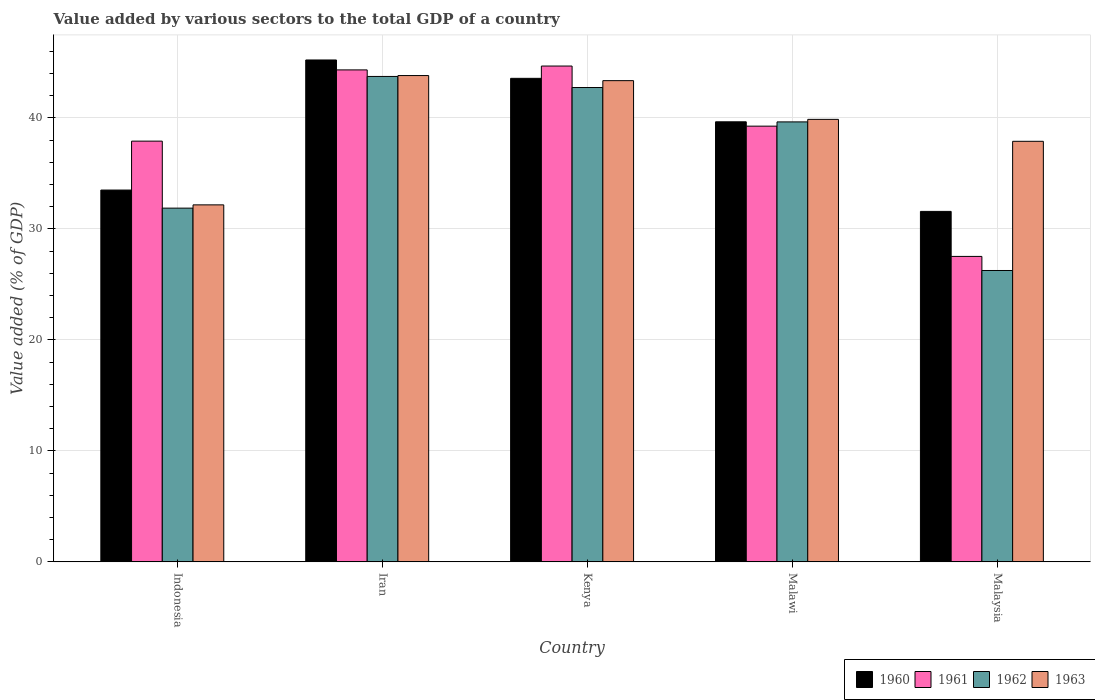How many different coloured bars are there?
Your response must be concise. 4. Are the number of bars per tick equal to the number of legend labels?
Your answer should be very brief. Yes. Are the number of bars on each tick of the X-axis equal?
Provide a succinct answer. Yes. What is the label of the 2nd group of bars from the left?
Provide a short and direct response. Iran. What is the value added by various sectors to the total GDP in 1960 in Indonesia?
Make the answer very short. 33.5. Across all countries, what is the maximum value added by various sectors to the total GDP in 1962?
Your answer should be very brief. 43.73. Across all countries, what is the minimum value added by various sectors to the total GDP in 1963?
Give a very brief answer. 32.16. In which country was the value added by various sectors to the total GDP in 1960 maximum?
Offer a terse response. Iran. In which country was the value added by various sectors to the total GDP in 1961 minimum?
Make the answer very short. Malaysia. What is the total value added by various sectors to the total GDP in 1960 in the graph?
Your response must be concise. 193.49. What is the difference between the value added by various sectors to the total GDP in 1960 in Iran and that in Malaysia?
Your response must be concise. 13.64. What is the difference between the value added by various sectors to the total GDP in 1963 in Malawi and the value added by various sectors to the total GDP in 1962 in Iran?
Offer a terse response. -3.87. What is the average value added by various sectors to the total GDP in 1960 per country?
Provide a succinct answer. 38.7. What is the difference between the value added by various sectors to the total GDP of/in 1961 and value added by various sectors to the total GDP of/in 1963 in Malaysia?
Offer a very short reply. -10.37. What is the ratio of the value added by various sectors to the total GDP in 1961 in Kenya to that in Malawi?
Your response must be concise. 1.14. Is the value added by various sectors to the total GDP in 1960 in Iran less than that in Malawi?
Give a very brief answer. No. What is the difference between the highest and the second highest value added by various sectors to the total GDP in 1963?
Give a very brief answer. -0.46. What is the difference between the highest and the lowest value added by various sectors to the total GDP in 1963?
Offer a terse response. 11.65. In how many countries, is the value added by various sectors to the total GDP in 1961 greater than the average value added by various sectors to the total GDP in 1961 taken over all countries?
Your answer should be very brief. 3. Is the sum of the value added by various sectors to the total GDP in 1960 in Indonesia and Kenya greater than the maximum value added by various sectors to the total GDP in 1961 across all countries?
Your response must be concise. Yes. What does the 2nd bar from the right in Malaysia represents?
Offer a very short reply. 1962. Is it the case that in every country, the sum of the value added by various sectors to the total GDP in 1963 and value added by various sectors to the total GDP in 1962 is greater than the value added by various sectors to the total GDP in 1960?
Make the answer very short. Yes. Are all the bars in the graph horizontal?
Your answer should be very brief. No. Are the values on the major ticks of Y-axis written in scientific E-notation?
Provide a succinct answer. No. Where does the legend appear in the graph?
Offer a terse response. Bottom right. How many legend labels are there?
Keep it short and to the point. 4. How are the legend labels stacked?
Your answer should be very brief. Horizontal. What is the title of the graph?
Offer a very short reply. Value added by various sectors to the total GDP of a country. What is the label or title of the Y-axis?
Provide a short and direct response. Value added (% of GDP). What is the Value added (% of GDP) in 1960 in Indonesia?
Ensure brevity in your answer.  33.5. What is the Value added (% of GDP) in 1961 in Indonesia?
Ensure brevity in your answer.  37.9. What is the Value added (% of GDP) of 1962 in Indonesia?
Ensure brevity in your answer.  31.87. What is the Value added (% of GDP) of 1963 in Indonesia?
Ensure brevity in your answer.  32.16. What is the Value added (% of GDP) of 1960 in Iran?
Your answer should be compact. 45.21. What is the Value added (% of GDP) of 1961 in Iran?
Offer a terse response. 44.32. What is the Value added (% of GDP) in 1962 in Iran?
Give a very brief answer. 43.73. What is the Value added (% of GDP) of 1963 in Iran?
Your answer should be very brief. 43.81. What is the Value added (% of GDP) of 1960 in Kenya?
Give a very brief answer. 43.56. What is the Value added (% of GDP) in 1961 in Kenya?
Your answer should be compact. 44.67. What is the Value added (% of GDP) of 1962 in Kenya?
Your answer should be very brief. 42.73. What is the Value added (% of GDP) in 1963 in Kenya?
Keep it short and to the point. 43.35. What is the Value added (% of GDP) in 1960 in Malawi?
Your answer should be very brief. 39.64. What is the Value added (% of GDP) in 1961 in Malawi?
Give a very brief answer. 39.25. What is the Value added (% of GDP) in 1962 in Malawi?
Make the answer very short. 39.64. What is the Value added (% of GDP) of 1963 in Malawi?
Keep it short and to the point. 39.86. What is the Value added (% of GDP) in 1960 in Malaysia?
Your answer should be compact. 31.57. What is the Value added (% of GDP) of 1961 in Malaysia?
Your answer should be very brief. 27.52. What is the Value added (% of GDP) of 1962 in Malaysia?
Your response must be concise. 26.25. What is the Value added (% of GDP) of 1963 in Malaysia?
Give a very brief answer. 37.89. Across all countries, what is the maximum Value added (% of GDP) of 1960?
Your answer should be compact. 45.21. Across all countries, what is the maximum Value added (% of GDP) in 1961?
Provide a succinct answer. 44.67. Across all countries, what is the maximum Value added (% of GDP) in 1962?
Provide a succinct answer. 43.73. Across all countries, what is the maximum Value added (% of GDP) in 1963?
Provide a short and direct response. 43.81. Across all countries, what is the minimum Value added (% of GDP) in 1960?
Offer a very short reply. 31.57. Across all countries, what is the minimum Value added (% of GDP) in 1961?
Your answer should be very brief. 27.52. Across all countries, what is the minimum Value added (% of GDP) of 1962?
Make the answer very short. 26.25. Across all countries, what is the minimum Value added (% of GDP) in 1963?
Ensure brevity in your answer.  32.16. What is the total Value added (% of GDP) of 1960 in the graph?
Offer a terse response. 193.49. What is the total Value added (% of GDP) of 1961 in the graph?
Your response must be concise. 193.66. What is the total Value added (% of GDP) in 1962 in the graph?
Ensure brevity in your answer.  184.21. What is the total Value added (% of GDP) of 1963 in the graph?
Your answer should be compact. 197.08. What is the difference between the Value added (% of GDP) in 1960 in Indonesia and that in Iran?
Give a very brief answer. -11.72. What is the difference between the Value added (% of GDP) of 1961 in Indonesia and that in Iran?
Your answer should be very brief. -6.42. What is the difference between the Value added (% of GDP) of 1962 in Indonesia and that in Iran?
Your answer should be compact. -11.86. What is the difference between the Value added (% of GDP) in 1963 in Indonesia and that in Iran?
Provide a succinct answer. -11.65. What is the difference between the Value added (% of GDP) in 1960 in Indonesia and that in Kenya?
Provide a short and direct response. -10.06. What is the difference between the Value added (% of GDP) of 1961 in Indonesia and that in Kenya?
Make the answer very short. -6.76. What is the difference between the Value added (% of GDP) of 1962 in Indonesia and that in Kenya?
Your response must be concise. -10.87. What is the difference between the Value added (% of GDP) in 1963 in Indonesia and that in Kenya?
Give a very brief answer. -11.19. What is the difference between the Value added (% of GDP) in 1960 in Indonesia and that in Malawi?
Provide a short and direct response. -6.15. What is the difference between the Value added (% of GDP) of 1961 in Indonesia and that in Malawi?
Make the answer very short. -1.35. What is the difference between the Value added (% of GDP) of 1962 in Indonesia and that in Malawi?
Offer a very short reply. -7.77. What is the difference between the Value added (% of GDP) of 1963 in Indonesia and that in Malawi?
Your answer should be compact. -7.7. What is the difference between the Value added (% of GDP) in 1960 in Indonesia and that in Malaysia?
Give a very brief answer. 1.92. What is the difference between the Value added (% of GDP) in 1961 in Indonesia and that in Malaysia?
Give a very brief answer. 10.39. What is the difference between the Value added (% of GDP) in 1962 in Indonesia and that in Malaysia?
Keep it short and to the point. 5.62. What is the difference between the Value added (% of GDP) of 1963 in Indonesia and that in Malaysia?
Keep it short and to the point. -5.73. What is the difference between the Value added (% of GDP) of 1960 in Iran and that in Kenya?
Provide a succinct answer. 1.65. What is the difference between the Value added (% of GDP) of 1961 in Iran and that in Kenya?
Offer a terse response. -0.35. What is the difference between the Value added (% of GDP) of 1962 in Iran and that in Kenya?
Give a very brief answer. 1. What is the difference between the Value added (% of GDP) of 1963 in Iran and that in Kenya?
Offer a very short reply. 0.46. What is the difference between the Value added (% of GDP) of 1960 in Iran and that in Malawi?
Provide a succinct answer. 5.57. What is the difference between the Value added (% of GDP) in 1961 in Iran and that in Malawi?
Provide a succinct answer. 5.07. What is the difference between the Value added (% of GDP) in 1962 in Iran and that in Malawi?
Make the answer very short. 4.09. What is the difference between the Value added (% of GDP) of 1963 in Iran and that in Malawi?
Ensure brevity in your answer.  3.95. What is the difference between the Value added (% of GDP) of 1960 in Iran and that in Malaysia?
Offer a terse response. 13.64. What is the difference between the Value added (% of GDP) in 1961 in Iran and that in Malaysia?
Ensure brevity in your answer.  16.8. What is the difference between the Value added (% of GDP) in 1962 in Iran and that in Malaysia?
Offer a terse response. 17.48. What is the difference between the Value added (% of GDP) in 1963 in Iran and that in Malaysia?
Provide a succinct answer. 5.92. What is the difference between the Value added (% of GDP) in 1960 in Kenya and that in Malawi?
Make the answer very short. 3.92. What is the difference between the Value added (% of GDP) of 1961 in Kenya and that in Malawi?
Provide a short and direct response. 5.41. What is the difference between the Value added (% of GDP) of 1962 in Kenya and that in Malawi?
Provide a short and direct response. 3.1. What is the difference between the Value added (% of GDP) in 1963 in Kenya and that in Malawi?
Offer a terse response. 3.49. What is the difference between the Value added (% of GDP) of 1960 in Kenya and that in Malaysia?
Offer a terse response. 11.99. What is the difference between the Value added (% of GDP) of 1961 in Kenya and that in Malaysia?
Keep it short and to the point. 17.15. What is the difference between the Value added (% of GDP) of 1962 in Kenya and that in Malaysia?
Make the answer very short. 16.48. What is the difference between the Value added (% of GDP) of 1963 in Kenya and that in Malaysia?
Your response must be concise. 5.46. What is the difference between the Value added (% of GDP) of 1960 in Malawi and that in Malaysia?
Your answer should be compact. 8.07. What is the difference between the Value added (% of GDP) in 1961 in Malawi and that in Malaysia?
Ensure brevity in your answer.  11.73. What is the difference between the Value added (% of GDP) of 1962 in Malawi and that in Malaysia?
Offer a terse response. 13.39. What is the difference between the Value added (% of GDP) of 1963 in Malawi and that in Malaysia?
Offer a terse response. 1.98. What is the difference between the Value added (% of GDP) in 1960 in Indonesia and the Value added (% of GDP) in 1961 in Iran?
Your response must be concise. -10.82. What is the difference between the Value added (% of GDP) in 1960 in Indonesia and the Value added (% of GDP) in 1962 in Iran?
Give a very brief answer. -10.24. What is the difference between the Value added (% of GDP) of 1960 in Indonesia and the Value added (% of GDP) of 1963 in Iran?
Make the answer very short. -10.32. What is the difference between the Value added (% of GDP) in 1961 in Indonesia and the Value added (% of GDP) in 1962 in Iran?
Make the answer very short. -5.83. What is the difference between the Value added (% of GDP) in 1961 in Indonesia and the Value added (% of GDP) in 1963 in Iran?
Give a very brief answer. -5.91. What is the difference between the Value added (% of GDP) in 1962 in Indonesia and the Value added (% of GDP) in 1963 in Iran?
Your response must be concise. -11.94. What is the difference between the Value added (% of GDP) of 1960 in Indonesia and the Value added (% of GDP) of 1961 in Kenya?
Your response must be concise. -11.17. What is the difference between the Value added (% of GDP) of 1960 in Indonesia and the Value added (% of GDP) of 1962 in Kenya?
Ensure brevity in your answer.  -9.24. What is the difference between the Value added (% of GDP) of 1960 in Indonesia and the Value added (% of GDP) of 1963 in Kenya?
Offer a terse response. -9.86. What is the difference between the Value added (% of GDP) in 1961 in Indonesia and the Value added (% of GDP) in 1962 in Kenya?
Ensure brevity in your answer.  -4.83. What is the difference between the Value added (% of GDP) of 1961 in Indonesia and the Value added (% of GDP) of 1963 in Kenya?
Keep it short and to the point. -5.45. What is the difference between the Value added (% of GDP) of 1962 in Indonesia and the Value added (% of GDP) of 1963 in Kenya?
Make the answer very short. -11.48. What is the difference between the Value added (% of GDP) in 1960 in Indonesia and the Value added (% of GDP) in 1961 in Malawi?
Make the answer very short. -5.76. What is the difference between the Value added (% of GDP) in 1960 in Indonesia and the Value added (% of GDP) in 1962 in Malawi?
Keep it short and to the point. -6.14. What is the difference between the Value added (% of GDP) of 1960 in Indonesia and the Value added (% of GDP) of 1963 in Malawi?
Provide a succinct answer. -6.37. What is the difference between the Value added (% of GDP) in 1961 in Indonesia and the Value added (% of GDP) in 1962 in Malawi?
Offer a very short reply. -1.73. What is the difference between the Value added (% of GDP) of 1961 in Indonesia and the Value added (% of GDP) of 1963 in Malawi?
Make the answer very short. -1.96. What is the difference between the Value added (% of GDP) of 1962 in Indonesia and the Value added (% of GDP) of 1963 in Malawi?
Offer a very short reply. -8. What is the difference between the Value added (% of GDP) of 1960 in Indonesia and the Value added (% of GDP) of 1961 in Malaysia?
Offer a very short reply. 5.98. What is the difference between the Value added (% of GDP) of 1960 in Indonesia and the Value added (% of GDP) of 1962 in Malaysia?
Give a very brief answer. 7.25. What is the difference between the Value added (% of GDP) in 1960 in Indonesia and the Value added (% of GDP) in 1963 in Malaysia?
Provide a succinct answer. -4.39. What is the difference between the Value added (% of GDP) in 1961 in Indonesia and the Value added (% of GDP) in 1962 in Malaysia?
Ensure brevity in your answer.  11.65. What is the difference between the Value added (% of GDP) in 1961 in Indonesia and the Value added (% of GDP) in 1963 in Malaysia?
Make the answer very short. 0.02. What is the difference between the Value added (% of GDP) in 1962 in Indonesia and the Value added (% of GDP) in 1963 in Malaysia?
Offer a terse response. -6.02. What is the difference between the Value added (% of GDP) in 1960 in Iran and the Value added (% of GDP) in 1961 in Kenya?
Give a very brief answer. 0.55. What is the difference between the Value added (% of GDP) in 1960 in Iran and the Value added (% of GDP) in 1962 in Kenya?
Keep it short and to the point. 2.48. What is the difference between the Value added (% of GDP) of 1960 in Iran and the Value added (% of GDP) of 1963 in Kenya?
Offer a very short reply. 1.86. What is the difference between the Value added (% of GDP) of 1961 in Iran and the Value added (% of GDP) of 1962 in Kenya?
Provide a succinct answer. 1.59. What is the difference between the Value added (% of GDP) in 1961 in Iran and the Value added (% of GDP) in 1963 in Kenya?
Your answer should be compact. 0.97. What is the difference between the Value added (% of GDP) in 1962 in Iran and the Value added (% of GDP) in 1963 in Kenya?
Offer a very short reply. 0.38. What is the difference between the Value added (% of GDP) of 1960 in Iran and the Value added (% of GDP) of 1961 in Malawi?
Keep it short and to the point. 5.96. What is the difference between the Value added (% of GDP) in 1960 in Iran and the Value added (% of GDP) in 1962 in Malawi?
Make the answer very short. 5.58. What is the difference between the Value added (% of GDP) of 1960 in Iran and the Value added (% of GDP) of 1963 in Malawi?
Your answer should be compact. 5.35. What is the difference between the Value added (% of GDP) of 1961 in Iran and the Value added (% of GDP) of 1962 in Malawi?
Your answer should be very brief. 4.68. What is the difference between the Value added (% of GDP) of 1961 in Iran and the Value added (% of GDP) of 1963 in Malawi?
Give a very brief answer. 4.46. What is the difference between the Value added (% of GDP) in 1962 in Iran and the Value added (% of GDP) in 1963 in Malawi?
Ensure brevity in your answer.  3.87. What is the difference between the Value added (% of GDP) of 1960 in Iran and the Value added (% of GDP) of 1961 in Malaysia?
Give a very brief answer. 17.7. What is the difference between the Value added (% of GDP) in 1960 in Iran and the Value added (% of GDP) in 1962 in Malaysia?
Ensure brevity in your answer.  18.96. What is the difference between the Value added (% of GDP) of 1960 in Iran and the Value added (% of GDP) of 1963 in Malaysia?
Your response must be concise. 7.33. What is the difference between the Value added (% of GDP) in 1961 in Iran and the Value added (% of GDP) in 1962 in Malaysia?
Give a very brief answer. 18.07. What is the difference between the Value added (% of GDP) of 1961 in Iran and the Value added (% of GDP) of 1963 in Malaysia?
Offer a terse response. 6.43. What is the difference between the Value added (% of GDP) in 1962 in Iran and the Value added (% of GDP) in 1963 in Malaysia?
Your answer should be compact. 5.84. What is the difference between the Value added (% of GDP) in 1960 in Kenya and the Value added (% of GDP) in 1961 in Malawi?
Your answer should be very brief. 4.31. What is the difference between the Value added (% of GDP) in 1960 in Kenya and the Value added (% of GDP) in 1962 in Malawi?
Give a very brief answer. 3.92. What is the difference between the Value added (% of GDP) in 1960 in Kenya and the Value added (% of GDP) in 1963 in Malawi?
Ensure brevity in your answer.  3.7. What is the difference between the Value added (% of GDP) in 1961 in Kenya and the Value added (% of GDP) in 1962 in Malawi?
Give a very brief answer. 5.03. What is the difference between the Value added (% of GDP) in 1961 in Kenya and the Value added (% of GDP) in 1963 in Malawi?
Your answer should be compact. 4.8. What is the difference between the Value added (% of GDP) in 1962 in Kenya and the Value added (% of GDP) in 1963 in Malawi?
Ensure brevity in your answer.  2.87. What is the difference between the Value added (% of GDP) of 1960 in Kenya and the Value added (% of GDP) of 1961 in Malaysia?
Give a very brief answer. 16.04. What is the difference between the Value added (% of GDP) in 1960 in Kenya and the Value added (% of GDP) in 1962 in Malaysia?
Provide a succinct answer. 17.31. What is the difference between the Value added (% of GDP) in 1960 in Kenya and the Value added (% of GDP) in 1963 in Malaysia?
Give a very brief answer. 5.67. What is the difference between the Value added (% of GDP) in 1961 in Kenya and the Value added (% of GDP) in 1962 in Malaysia?
Offer a terse response. 18.42. What is the difference between the Value added (% of GDP) in 1961 in Kenya and the Value added (% of GDP) in 1963 in Malaysia?
Provide a succinct answer. 6.78. What is the difference between the Value added (% of GDP) of 1962 in Kenya and the Value added (% of GDP) of 1963 in Malaysia?
Offer a very short reply. 4.84. What is the difference between the Value added (% of GDP) in 1960 in Malawi and the Value added (% of GDP) in 1961 in Malaysia?
Provide a short and direct response. 12.13. What is the difference between the Value added (% of GDP) of 1960 in Malawi and the Value added (% of GDP) of 1962 in Malaysia?
Offer a very short reply. 13.39. What is the difference between the Value added (% of GDP) of 1960 in Malawi and the Value added (% of GDP) of 1963 in Malaysia?
Provide a short and direct response. 1.76. What is the difference between the Value added (% of GDP) of 1961 in Malawi and the Value added (% of GDP) of 1962 in Malaysia?
Your answer should be compact. 13. What is the difference between the Value added (% of GDP) in 1961 in Malawi and the Value added (% of GDP) in 1963 in Malaysia?
Provide a short and direct response. 1.37. What is the difference between the Value added (% of GDP) of 1962 in Malawi and the Value added (% of GDP) of 1963 in Malaysia?
Give a very brief answer. 1.75. What is the average Value added (% of GDP) in 1960 per country?
Give a very brief answer. 38.7. What is the average Value added (% of GDP) in 1961 per country?
Your answer should be very brief. 38.73. What is the average Value added (% of GDP) in 1962 per country?
Ensure brevity in your answer.  36.84. What is the average Value added (% of GDP) in 1963 per country?
Your response must be concise. 39.41. What is the difference between the Value added (% of GDP) of 1960 and Value added (% of GDP) of 1961 in Indonesia?
Give a very brief answer. -4.41. What is the difference between the Value added (% of GDP) in 1960 and Value added (% of GDP) in 1962 in Indonesia?
Your response must be concise. 1.63. What is the difference between the Value added (% of GDP) of 1961 and Value added (% of GDP) of 1962 in Indonesia?
Your answer should be very brief. 6.04. What is the difference between the Value added (% of GDP) of 1961 and Value added (% of GDP) of 1963 in Indonesia?
Keep it short and to the point. 5.74. What is the difference between the Value added (% of GDP) of 1962 and Value added (% of GDP) of 1963 in Indonesia?
Ensure brevity in your answer.  -0.3. What is the difference between the Value added (% of GDP) of 1960 and Value added (% of GDP) of 1961 in Iran?
Your answer should be very brief. 0.89. What is the difference between the Value added (% of GDP) of 1960 and Value added (% of GDP) of 1962 in Iran?
Your response must be concise. 1.48. What is the difference between the Value added (% of GDP) in 1960 and Value added (% of GDP) in 1963 in Iran?
Your response must be concise. 1.4. What is the difference between the Value added (% of GDP) in 1961 and Value added (% of GDP) in 1962 in Iran?
Give a very brief answer. 0.59. What is the difference between the Value added (% of GDP) in 1961 and Value added (% of GDP) in 1963 in Iran?
Make the answer very short. 0.51. What is the difference between the Value added (% of GDP) in 1962 and Value added (% of GDP) in 1963 in Iran?
Offer a very short reply. -0.08. What is the difference between the Value added (% of GDP) of 1960 and Value added (% of GDP) of 1961 in Kenya?
Ensure brevity in your answer.  -1.11. What is the difference between the Value added (% of GDP) in 1960 and Value added (% of GDP) in 1962 in Kenya?
Provide a short and direct response. 0.83. What is the difference between the Value added (% of GDP) in 1960 and Value added (% of GDP) in 1963 in Kenya?
Provide a succinct answer. 0.21. What is the difference between the Value added (% of GDP) in 1961 and Value added (% of GDP) in 1962 in Kenya?
Your response must be concise. 1.94. What is the difference between the Value added (% of GDP) of 1961 and Value added (% of GDP) of 1963 in Kenya?
Give a very brief answer. 1.32. What is the difference between the Value added (% of GDP) in 1962 and Value added (% of GDP) in 1963 in Kenya?
Provide a succinct answer. -0.62. What is the difference between the Value added (% of GDP) in 1960 and Value added (% of GDP) in 1961 in Malawi?
Keep it short and to the point. 0.39. What is the difference between the Value added (% of GDP) in 1960 and Value added (% of GDP) in 1962 in Malawi?
Your answer should be very brief. 0.01. What is the difference between the Value added (% of GDP) in 1960 and Value added (% of GDP) in 1963 in Malawi?
Your response must be concise. -0.22. What is the difference between the Value added (% of GDP) of 1961 and Value added (% of GDP) of 1962 in Malawi?
Provide a succinct answer. -0.38. What is the difference between the Value added (% of GDP) of 1961 and Value added (% of GDP) of 1963 in Malawi?
Offer a terse response. -0.61. What is the difference between the Value added (% of GDP) in 1962 and Value added (% of GDP) in 1963 in Malawi?
Provide a short and direct response. -0.23. What is the difference between the Value added (% of GDP) of 1960 and Value added (% of GDP) of 1961 in Malaysia?
Provide a short and direct response. 4.05. What is the difference between the Value added (% of GDP) of 1960 and Value added (% of GDP) of 1962 in Malaysia?
Your answer should be very brief. 5.32. What is the difference between the Value added (% of GDP) in 1960 and Value added (% of GDP) in 1963 in Malaysia?
Ensure brevity in your answer.  -6.31. What is the difference between the Value added (% of GDP) in 1961 and Value added (% of GDP) in 1962 in Malaysia?
Your response must be concise. 1.27. What is the difference between the Value added (% of GDP) of 1961 and Value added (% of GDP) of 1963 in Malaysia?
Keep it short and to the point. -10.37. What is the difference between the Value added (% of GDP) in 1962 and Value added (% of GDP) in 1963 in Malaysia?
Give a very brief answer. -11.64. What is the ratio of the Value added (% of GDP) of 1960 in Indonesia to that in Iran?
Your answer should be very brief. 0.74. What is the ratio of the Value added (% of GDP) of 1961 in Indonesia to that in Iran?
Your answer should be compact. 0.86. What is the ratio of the Value added (% of GDP) in 1962 in Indonesia to that in Iran?
Your answer should be very brief. 0.73. What is the ratio of the Value added (% of GDP) in 1963 in Indonesia to that in Iran?
Ensure brevity in your answer.  0.73. What is the ratio of the Value added (% of GDP) of 1960 in Indonesia to that in Kenya?
Provide a succinct answer. 0.77. What is the ratio of the Value added (% of GDP) in 1961 in Indonesia to that in Kenya?
Provide a succinct answer. 0.85. What is the ratio of the Value added (% of GDP) of 1962 in Indonesia to that in Kenya?
Your answer should be very brief. 0.75. What is the ratio of the Value added (% of GDP) of 1963 in Indonesia to that in Kenya?
Ensure brevity in your answer.  0.74. What is the ratio of the Value added (% of GDP) of 1960 in Indonesia to that in Malawi?
Your response must be concise. 0.84. What is the ratio of the Value added (% of GDP) of 1961 in Indonesia to that in Malawi?
Give a very brief answer. 0.97. What is the ratio of the Value added (% of GDP) in 1962 in Indonesia to that in Malawi?
Provide a short and direct response. 0.8. What is the ratio of the Value added (% of GDP) in 1963 in Indonesia to that in Malawi?
Your answer should be very brief. 0.81. What is the ratio of the Value added (% of GDP) in 1960 in Indonesia to that in Malaysia?
Your answer should be compact. 1.06. What is the ratio of the Value added (% of GDP) in 1961 in Indonesia to that in Malaysia?
Offer a terse response. 1.38. What is the ratio of the Value added (% of GDP) of 1962 in Indonesia to that in Malaysia?
Provide a short and direct response. 1.21. What is the ratio of the Value added (% of GDP) in 1963 in Indonesia to that in Malaysia?
Your answer should be very brief. 0.85. What is the ratio of the Value added (% of GDP) in 1960 in Iran to that in Kenya?
Give a very brief answer. 1.04. What is the ratio of the Value added (% of GDP) of 1961 in Iran to that in Kenya?
Your answer should be very brief. 0.99. What is the ratio of the Value added (% of GDP) of 1962 in Iran to that in Kenya?
Provide a short and direct response. 1.02. What is the ratio of the Value added (% of GDP) in 1963 in Iran to that in Kenya?
Your answer should be very brief. 1.01. What is the ratio of the Value added (% of GDP) of 1960 in Iran to that in Malawi?
Provide a short and direct response. 1.14. What is the ratio of the Value added (% of GDP) in 1961 in Iran to that in Malawi?
Ensure brevity in your answer.  1.13. What is the ratio of the Value added (% of GDP) of 1962 in Iran to that in Malawi?
Your answer should be very brief. 1.1. What is the ratio of the Value added (% of GDP) in 1963 in Iran to that in Malawi?
Your answer should be compact. 1.1. What is the ratio of the Value added (% of GDP) in 1960 in Iran to that in Malaysia?
Make the answer very short. 1.43. What is the ratio of the Value added (% of GDP) in 1961 in Iran to that in Malaysia?
Give a very brief answer. 1.61. What is the ratio of the Value added (% of GDP) in 1962 in Iran to that in Malaysia?
Offer a very short reply. 1.67. What is the ratio of the Value added (% of GDP) in 1963 in Iran to that in Malaysia?
Provide a short and direct response. 1.16. What is the ratio of the Value added (% of GDP) of 1960 in Kenya to that in Malawi?
Keep it short and to the point. 1.1. What is the ratio of the Value added (% of GDP) in 1961 in Kenya to that in Malawi?
Give a very brief answer. 1.14. What is the ratio of the Value added (% of GDP) of 1962 in Kenya to that in Malawi?
Provide a succinct answer. 1.08. What is the ratio of the Value added (% of GDP) in 1963 in Kenya to that in Malawi?
Give a very brief answer. 1.09. What is the ratio of the Value added (% of GDP) of 1960 in Kenya to that in Malaysia?
Make the answer very short. 1.38. What is the ratio of the Value added (% of GDP) in 1961 in Kenya to that in Malaysia?
Make the answer very short. 1.62. What is the ratio of the Value added (% of GDP) in 1962 in Kenya to that in Malaysia?
Provide a succinct answer. 1.63. What is the ratio of the Value added (% of GDP) of 1963 in Kenya to that in Malaysia?
Give a very brief answer. 1.14. What is the ratio of the Value added (% of GDP) in 1960 in Malawi to that in Malaysia?
Provide a succinct answer. 1.26. What is the ratio of the Value added (% of GDP) in 1961 in Malawi to that in Malaysia?
Provide a succinct answer. 1.43. What is the ratio of the Value added (% of GDP) of 1962 in Malawi to that in Malaysia?
Ensure brevity in your answer.  1.51. What is the ratio of the Value added (% of GDP) of 1963 in Malawi to that in Malaysia?
Make the answer very short. 1.05. What is the difference between the highest and the second highest Value added (% of GDP) of 1960?
Offer a terse response. 1.65. What is the difference between the highest and the second highest Value added (% of GDP) in 1961?
Offer a very short reply. 0.35. What is the difference between the highest and the second highest Value added (% of GDP) in 1963?
Offer a very short reply. 0.46. What is the difference between the highest and the lowest Value added (% of GDP) in 1960?
Keep it short and to the point. 13.64. What is the difference between the highest and the lowest Value added (% of GDP) in 1961?
Your answer should be compact. 17.15. What is the difference between the highest and the lowest Value added (% of GDP) in 1962?
Provide a short and direct response. 17.48. What is the difference between the highest and the lowest Value added (% of GDP) of 1963?
Provide a short and direct response. 11.65. 